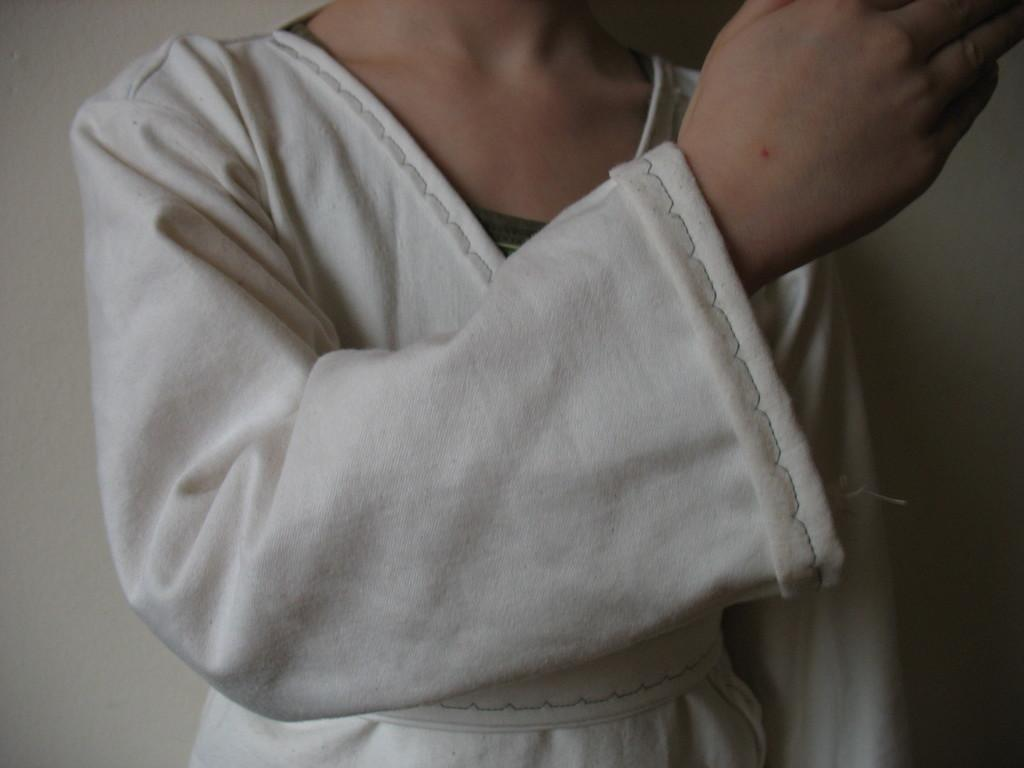Who or what is the main subject in the image? There is a person in the image. What is the person wearing? The person is wearing a white dress. What can be seen in the background of the image? The background of the image is white. Is the person taking a bath in the image? There is no indication in the image that the person is taking a bath. The image only shows a person wearing a white dress with a white background. 